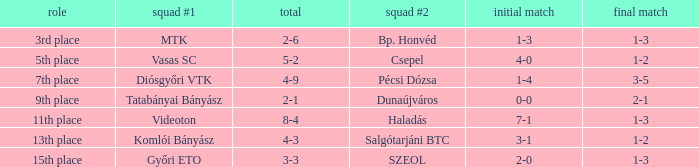What is the team #1 with an 11th place position? Videoton. 